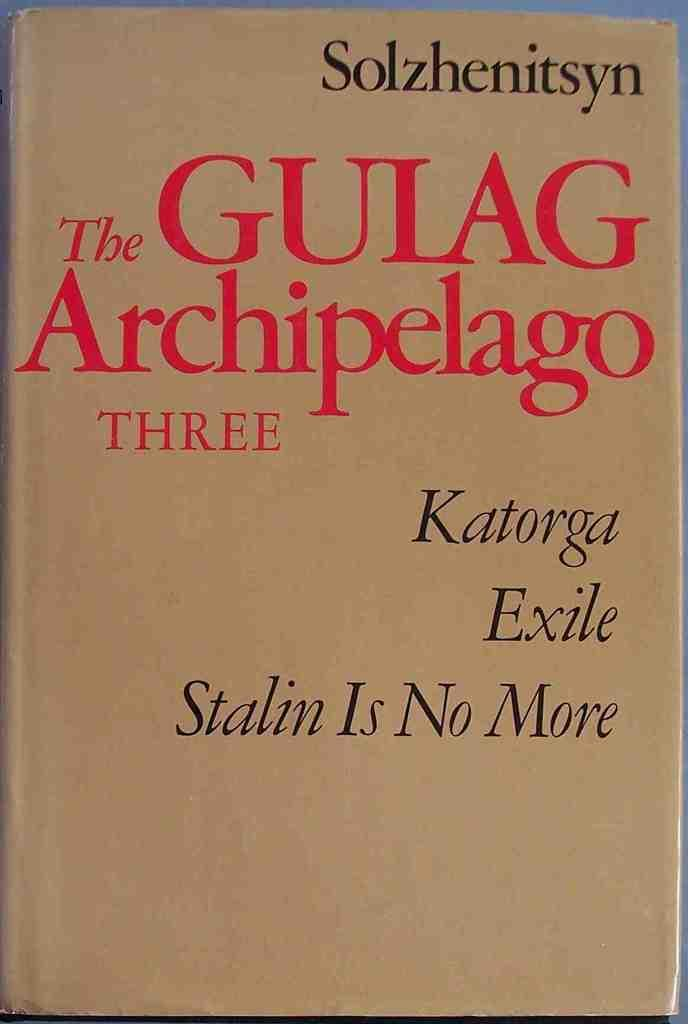<image>
Share a concise interpretation of the image provided. The Gulag Archipelago Three has a subtitle of Katorga Exile. 